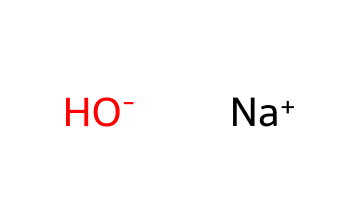What is the main component of sodium hydroxide? The chemical structure shows that sodium hydroxide consists of the sodium ion (Na+) and the hydroxide ion (OH-), which are the main components of this compound.
Answer: sodium and hydroxide How many atoms are present in sodium hydroxide? The chemical structure reveals that there are two distinct ions in sodium hydroxide: one sodium atom and one oxygen atom paired with one hydrogen atom in the hydroxide ion, totaling three atoms.
Answer: three What type of ion is sodium in this compound? The SMILES representation indicates that sodium in this compound is represented as Na+, which indicates it is a cation, meaning it has lost an electron and carries a positive charge.
Answer: cation What type of base is sodium hydroxide? Sodium hydroxide is classified as a strong base because it fully dissociates in water to produce hydroxide ions, resulting in a high pH when dissolved.
Answer: strong base What characteristic of sodium hydroxide contributes to its use in cleaning products? The presence of hydroxide ions (OH-) in sodium hydroxide makes it an effective cleaning agent, as these ions can saponify fats and break down organic matter, which is crucial for its cleaning properties.
Answer: hydroxide ions How does the presence of sodium ions affect the solubility of sodium hydroxide? Sodium ions increase the solubility of sodium hydroxide in water because they help to stabilize the hydroxide ions in solution, allowing for a greater concentration of the base in an aqueous environment.
Answer: increases solubility 